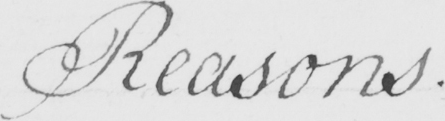Can you read and transcribe this handwriting? Reasons 